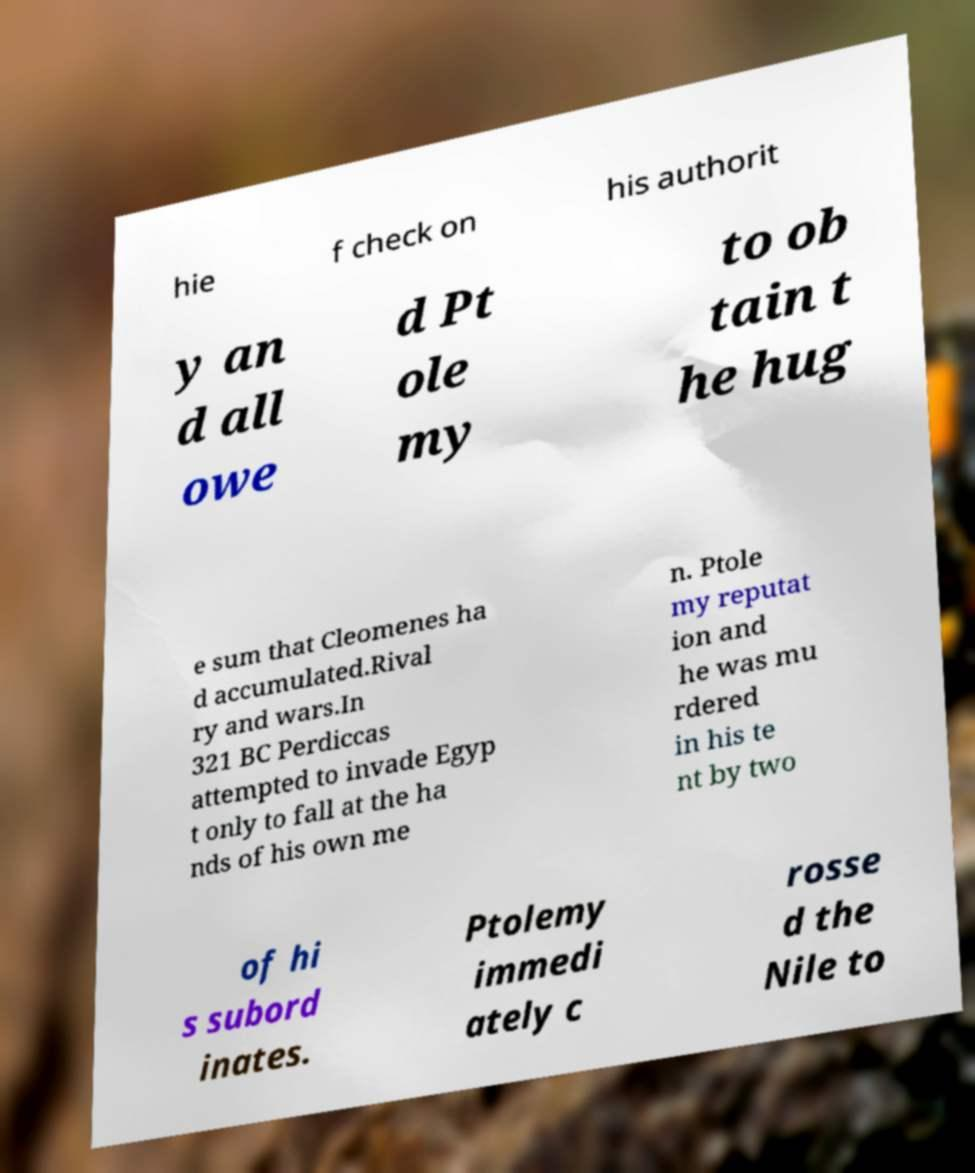Could you assist in decoding the text presented in this image and type it out clearly? hie f check on his authorit y an d all owe d Pt ole my to ob tain t he hug e sum that Cleomenes ha d accumulated.Rival ry and wars.In 321 BC Perdiccas attempted to invade Egyp t only to fall at the ha nds of his own me n. Ptole my reputat ion and he was mu rdered in his te nt by two of hi s subord inates. Ptolemy immedi ately c rosse d the Nile to 